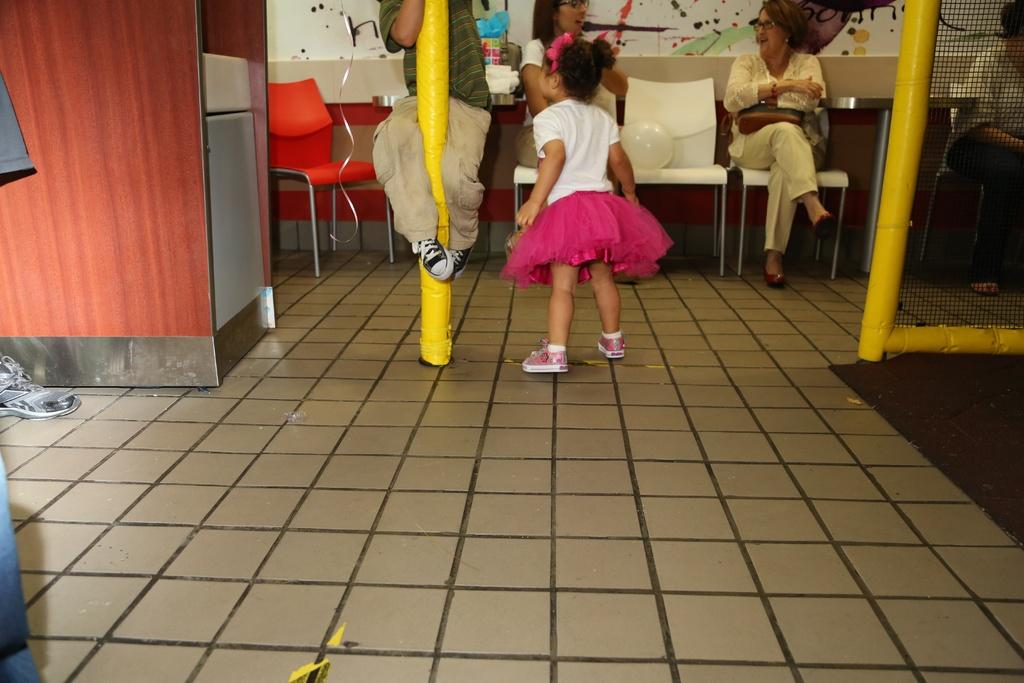How many people are in the image? There are people in the image, but the exact number is not specified. What type of furniture is present in the image? There are chairs and a table in the image. What can be seen on the right side of the image? There is a net and pole on the right side of the image. What items are on the left side of the image? There is a cupboard, shoe, and cloth on the left side of the image. What part of the room is visible at the bottom of the image? The floor is visible at the bottom of the image. What type of nose can be seen on the waves in the image? There are no waves or noses present in the image. 